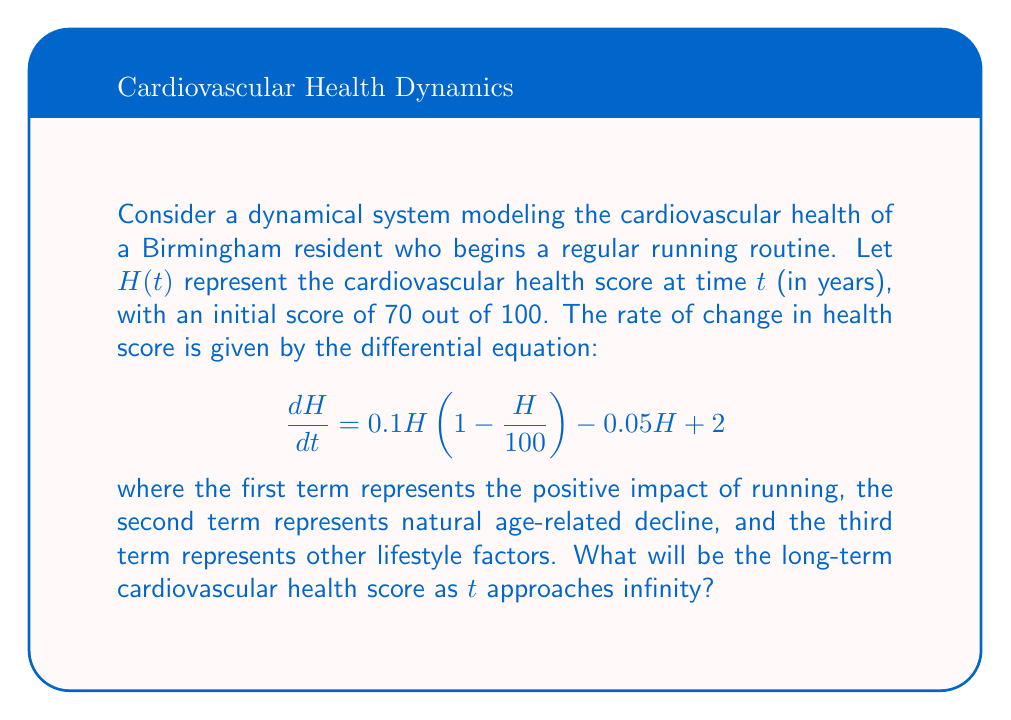Help me with this question. To find the long-term cardiovascular health score, we need to solve for the equilibrium point of the given differential equation. At equilibrium, $\frac{dH}{dt} = 0$.

Step 1: Set the equation equal to zero:
$$0 = 0.1H(1 - \frac{H}{100}) - 0.05H + 2$$

Step 2: Expand the equation:
$$0 = 0.1H - 0.001H^2 - 0.05H + 2$$

Step 3: Rearrange terms to standard quadratic form:
$$0.001H^2 - 0.05H - 2 = 0$$

Step 4: Solve using the quadratic formula $\frac{-b \pm \sqrt{b^2 - 4ac}}{2a}$:

$a = 0.001$, $b = -0.05$, $c = -2$

$$H = \frac{0.05 \pm \sqrt{(-0.05)^2 - 4(0.001)(-2)}}{2(0.001)}$$

Step 5: Simplify:
$$H = \frac{0.05 \pm \sqrt{0.0025 + 0.008}}{0.002} = \frac{0.05 \pm \sqrt{0.0105}}{0.002}$$

Step 6: Calculate the two solutions:
$$H_1 \approx 90.72, H_2 \approx -65.72$$

Step 7: Since health score cannot be negative, we discard the negative solution.

Therefore, the long-term cardiovascular health score will approach 90.72 out of 100 as time approaches infinity.
Answer: 90.72 